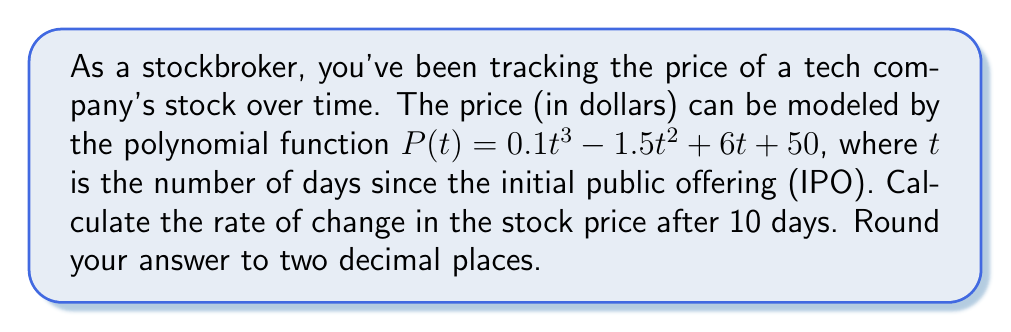Provide a solution to this math problem. To find the rate of change in the stock price after 10 days, we need to calculate the derivative of the polynomial function $P(t)$ and then evaluate it at $t = 10$.

1. Given function: $P(t) = 0.1t^3 - 1.5t^2 + 6t + 50$

2. Calculate the derivative $P'(t)$:
   $$P'(t) = 0.3t^2 - 3t + 6$$

   This is done by applying the power rule:
   - $\frac{d}{dt}(0.1t^3) = 3 \cdot 0.1t^2 = 0.3t^2$
   - $\frac{d}{dt}(-1.5t^2) = 2 \cdot (-1.5t) = -3t$
   - $\frac{d}{dt}(6t) = 6$
   - $\frac{d}{dt}(50) = 0$

3. Evaluate $P'(t)$ at $t = 10$:
   $$P'(10) = 0.3(10)^2 - 3(10) + 6$$
   $$= 0.3(100) - 30 + 6$$
   $$= 30 - 30 + 6$$
   $$= 6$$

4. Round the result to two decimal places: 6.00

The rate of change represents the instantaneous change in the stock price, measured in dollars per day.
Answer: $6.00 per day 